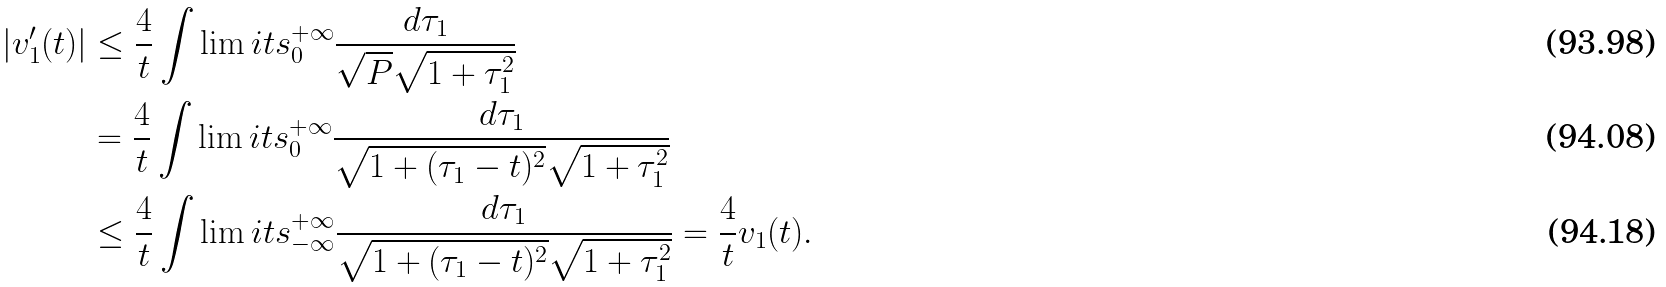Convert formula to latex. <formula><loc_0><loc_0><loc_500><loc_500>| v ^ { \prime } _ { 1 } ( t ) | & \leq \frac { 4 } { t } \int \lim i t s _ { 0 } ^ { + \infty } \frac { d \tau _ { 1 } } { \sqrt { P } \sqrt { 1 + \tau _ { 1 } ^ { 2 } } } \\ & = \frac { 4 } { t } \int \lim i t s _ { 0 } ^ { + \infty } \frac { d \tau _ { 1 } } { \sqrt { 1 + ( \tau _ { 1 } - t ) ^ { 2 } } \sqrt { 1 + \tau _ { 1 } ^ { 2 } } } \\ & \leq \frac { 4 } { t } \int \lim i t s _ { - \infty } ^ { + \infty } \frac { d \tau _ { 1 } } { \sqrt { 1 + ( \tau _ { 1 } - t ) ^ { 2 } } \sqrt { 1 + \tau _ { 1 } ^ { 2 } } } = \frac { 4 } { t } v _ { 1 } ( t ) .</formula> 